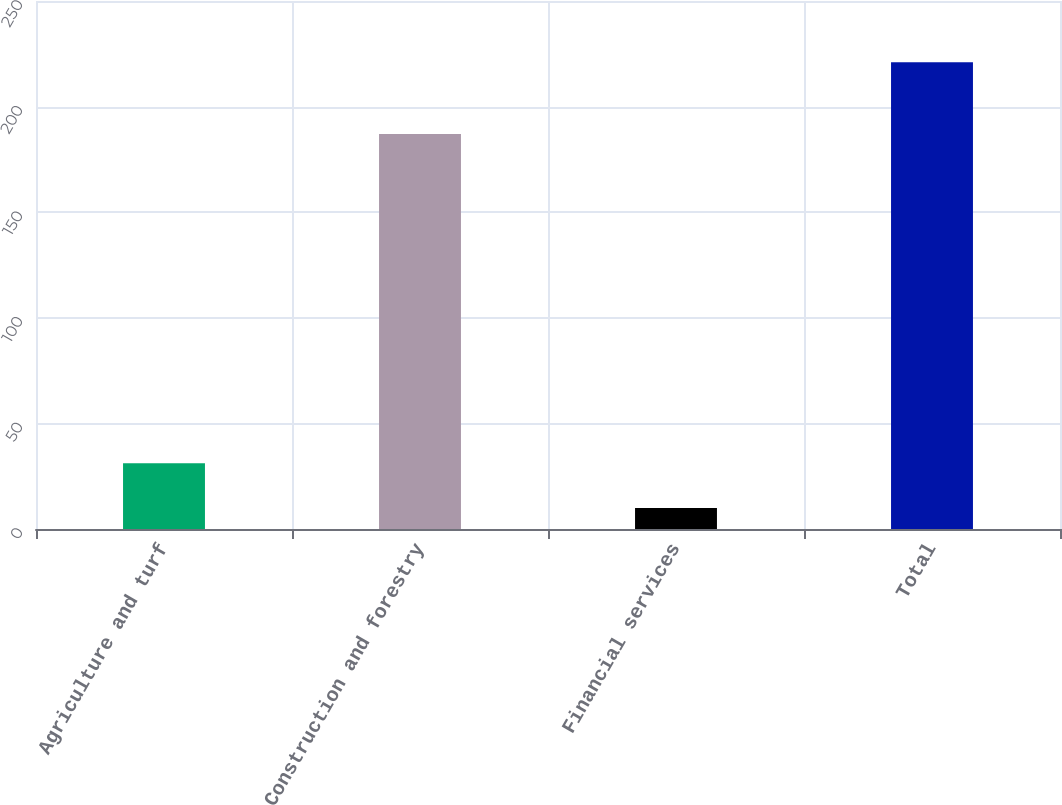<chart> <loc_0><loc_0><loc_500><loc_500><bar_chart><fcel>Agriculture and turf<fcel>Construction and forestry<fcel>Financial services<fcel>Total<nl><fcel>31.1<fcel>187<fcel>10<fcel>221<nl></chart> 